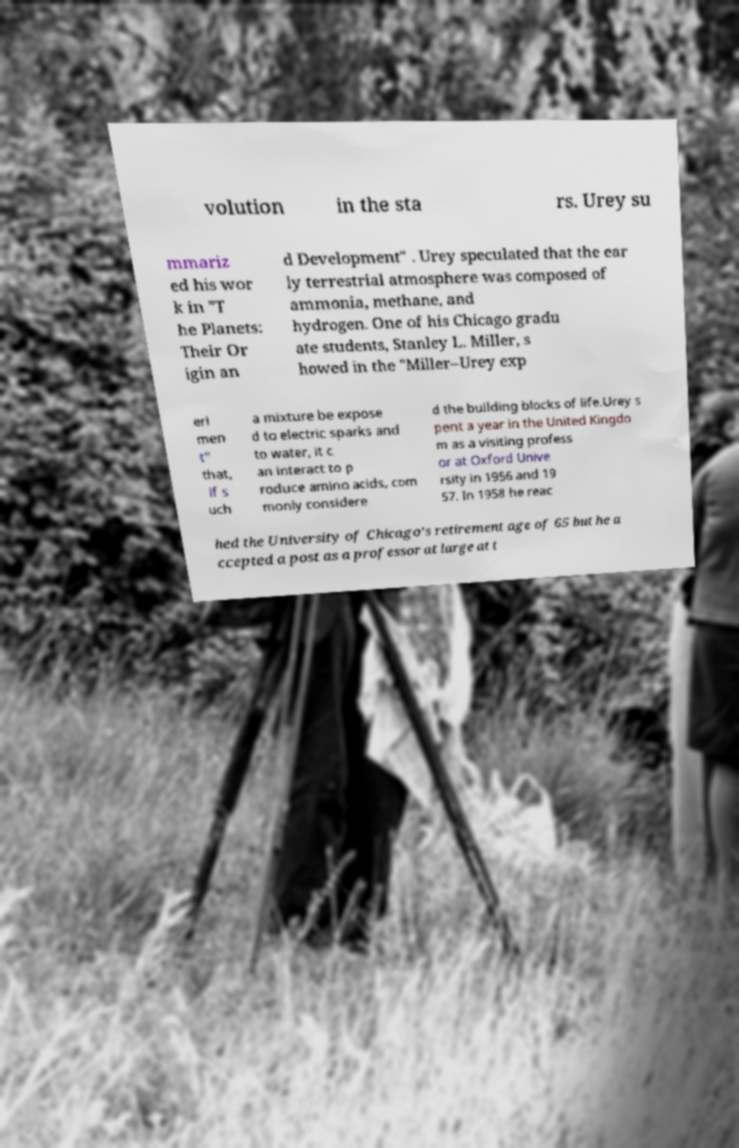For documentation purposes, I need the text within this image transcribed. Could you provide that? volution in the sta rs. Urey su mmariz ed his wor k in "T he Planets: Their Or igin an d Development" . Urey speculated that the ear ly terrestrial atmosphere was composed of ammonia, methane, and hydrogen. One of his Chicago gradu ate students, Stanley L. Miller, s howed in the "Miller–Urey exp eri men t" that, if s uch a mixture be expose d to electric sparks and to water, it c an interact to p roduce amino acids, com monly considere d the building blocks of life.Urey s pent a year in the United Kingdo m as a visiting profess or at Oxford Unive rsity in 1956 and 19 57. In 1958 he reac hed the University of Chicago's retirement age of 65 but he a ccepted a post as a professor at large at t 